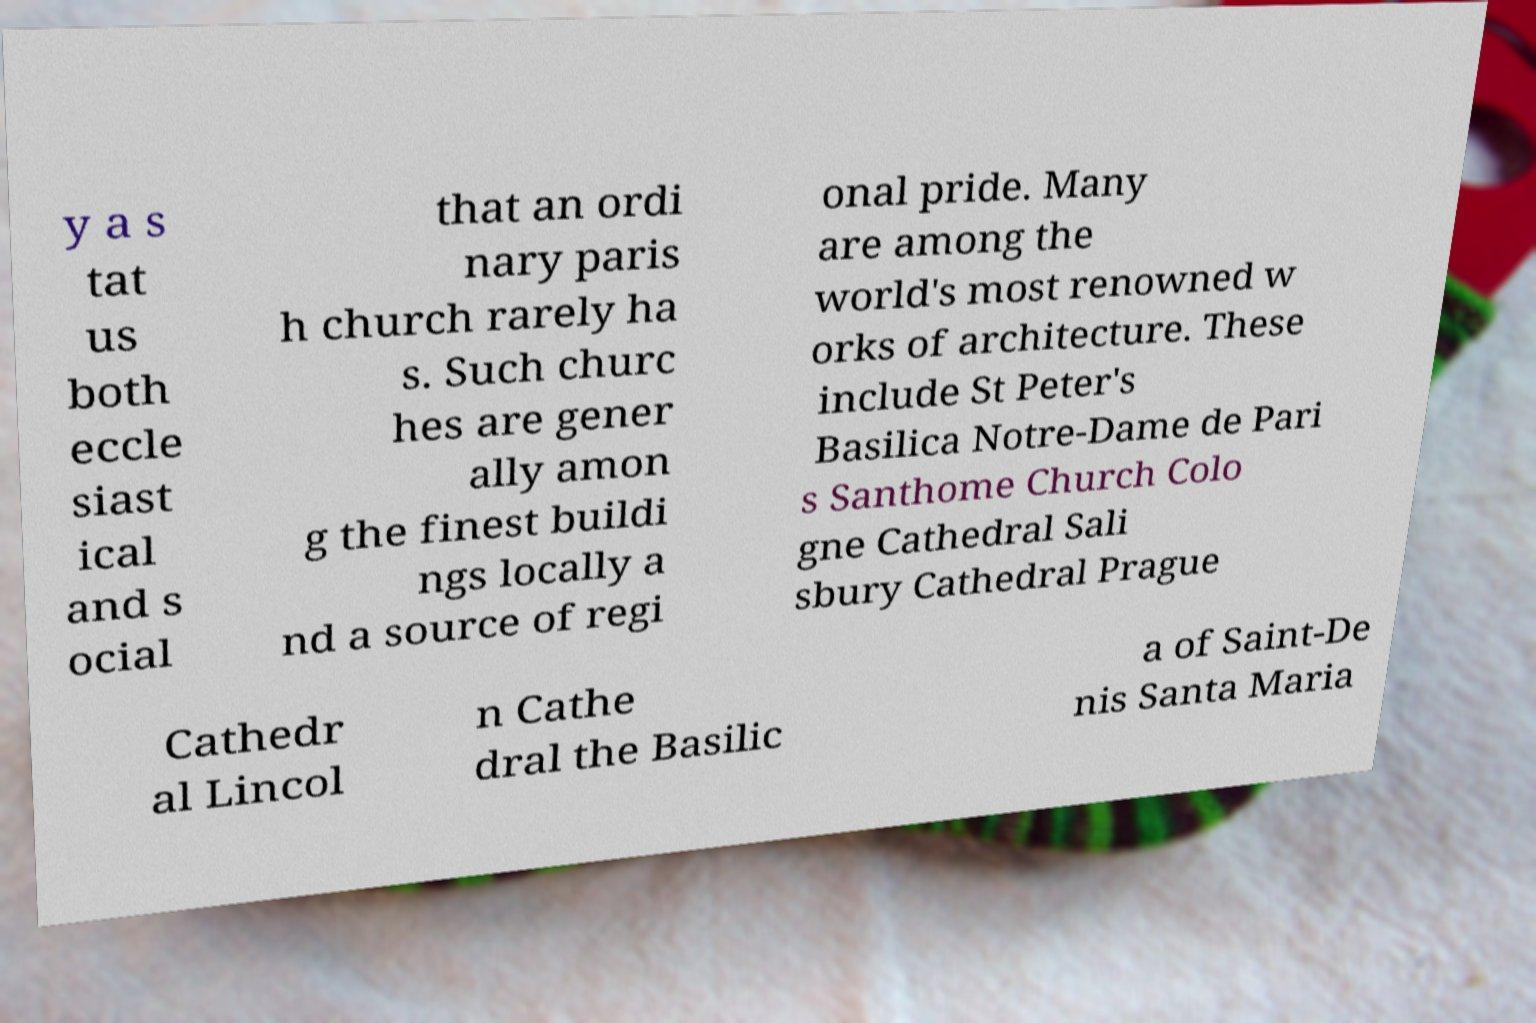For documentation purposes, I need the text within this image transcribed. Could you provide that? y a s tat us both eccle siast ical and s ocial that an ordi nary paris h church rarely ha s. Such churc hes are gener ally amon g the finest buildi ngs locally a nd a source of regi onal pride. Many are among the world's most renowned w orks of architecture. These include St Peter's Basilica Notre-Dame de Pari s Santhome Church Colo gne Cathedral Sali sbury Cathedral Prague Cathedr al Lincol n Cathe dral the Basilic a of Saint-De nis Santa Maria 